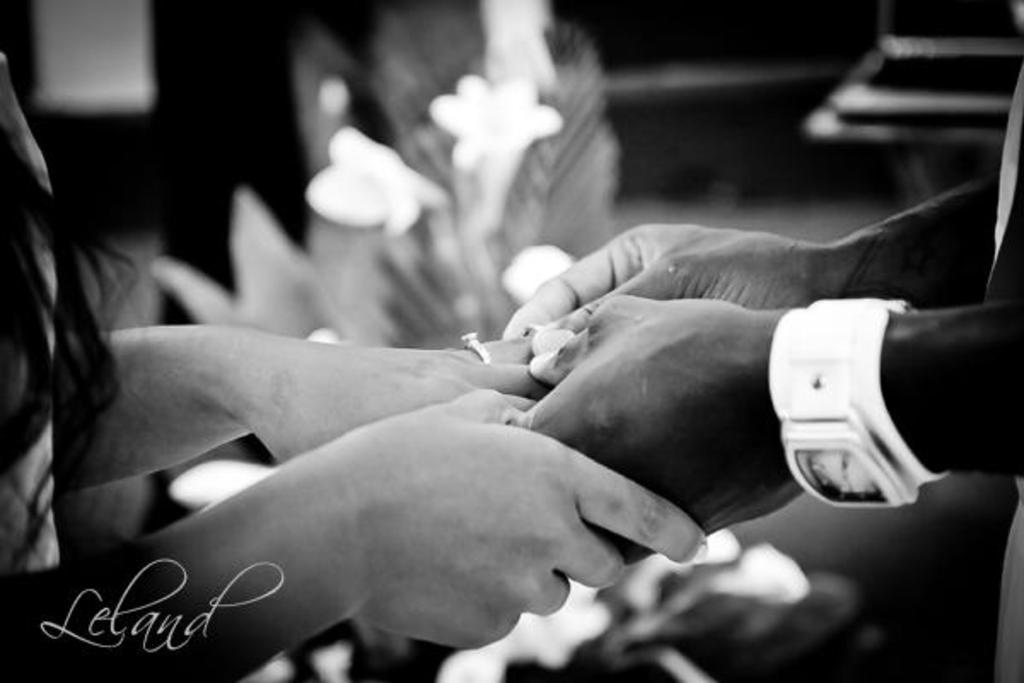How many people are present in the image? There are two persons in the image. What are the two persons doing in the image? The two persons are changing rings. What type of event might be taking place in the image? The scene appears to be a wedding. What can be seen in the background of the image? There is a flower bouquet in the background of the image. Can you tell me how many times the airplane flies over the scene in the image? There is no airplane present in the image, so it cannot be determined how many times it flies over the scene. 